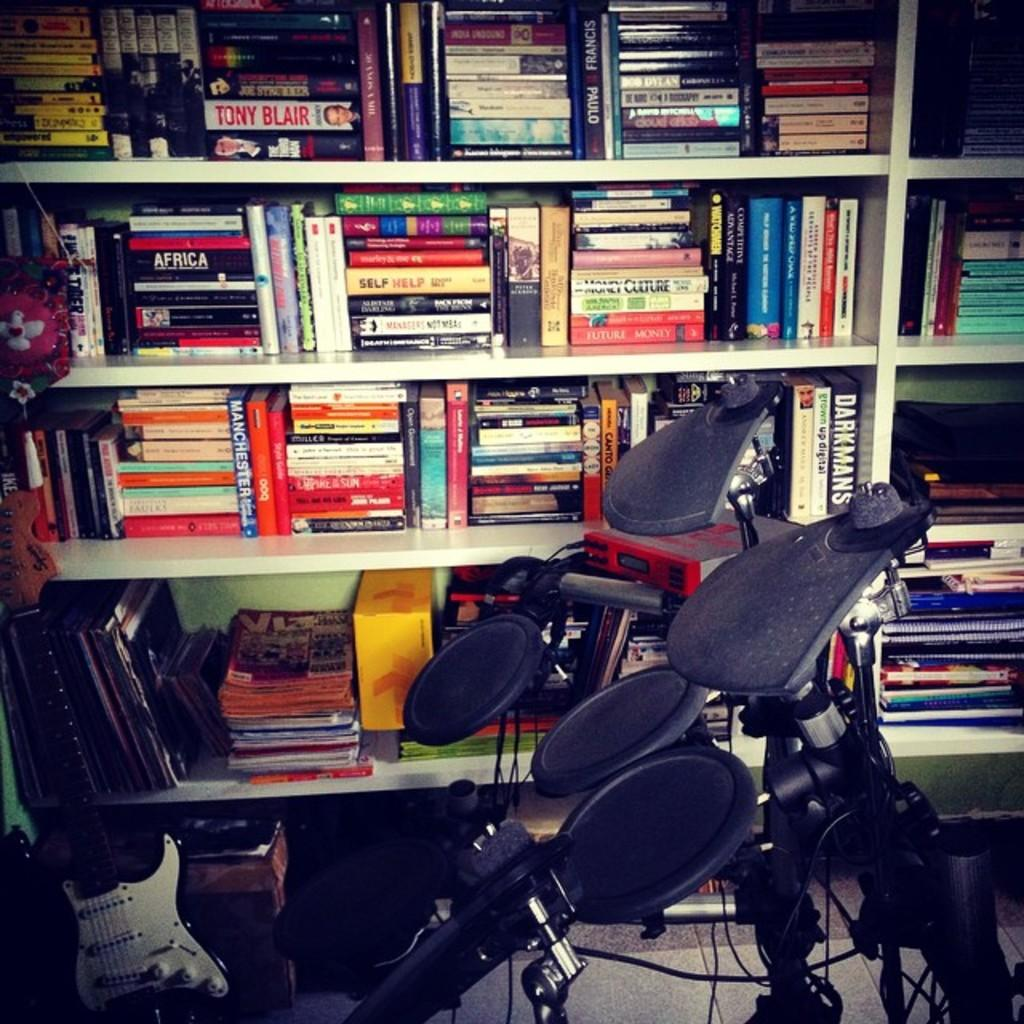<image>
Create a compact narrative representing the image presented. Book shelf that has a book titled Money Culture. 